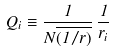Convert formula to latex. <formula><loc_0><loc_0><loc_500><loc_500>Q _ { i } \equiv \frac { 1 } { N \overline { ( { 1 } / { r } ) } } \, \frac { 1 } { r _ { i } }</formula> 